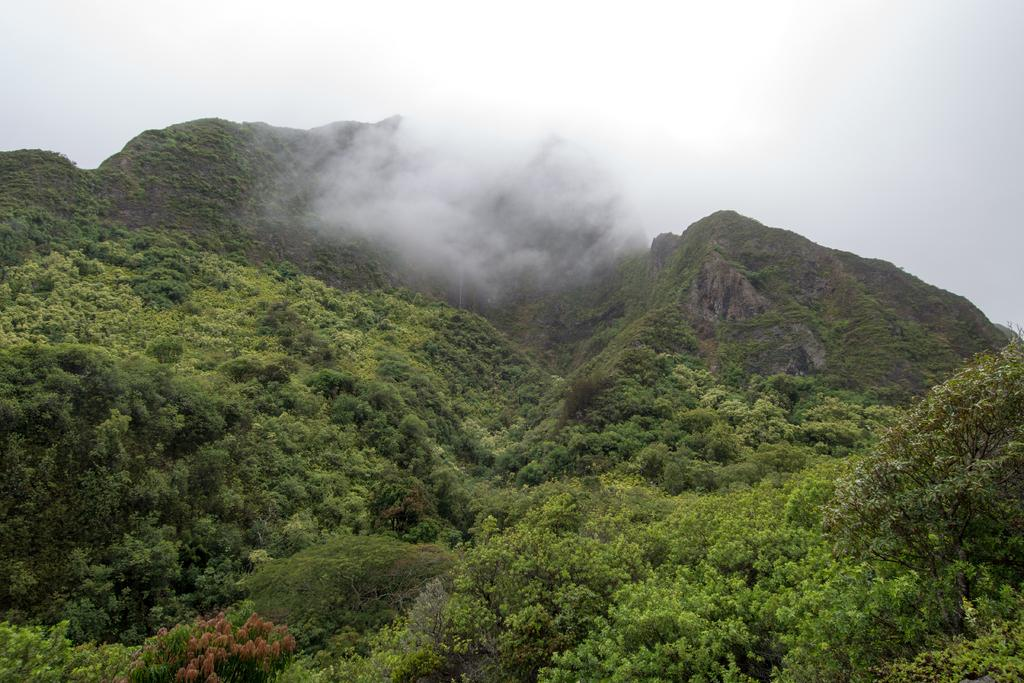What type of landscape is depicted in the image? The image features hills. What can be seen on the hills? Trees and plants are visible on the hills. What is visible in the background of the image? The sky is visible in the image. What is the condition of the sky in the image? Clouds are present in the sky. What type of shoes are the hills wearing in the image? The hills are not wearing shoes, as they are a natural landscape feature. 